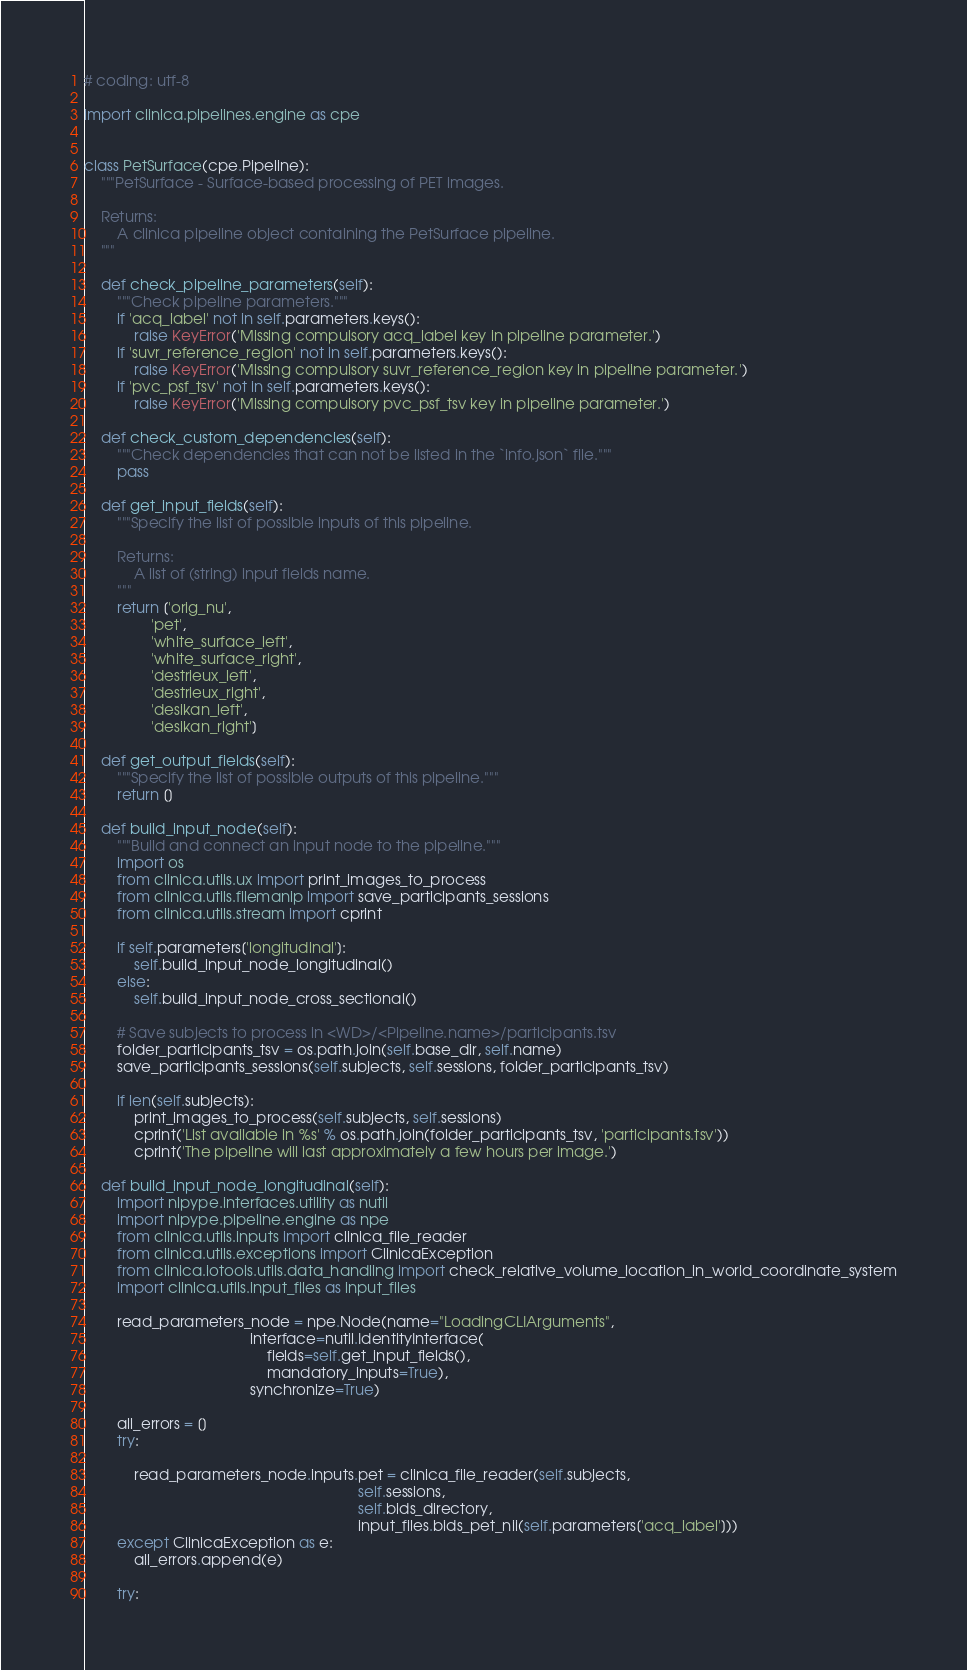<code> <loc_0><loc_0><loc_500><loc_500><_Python_># coding: utf-8

import clinica.pipelines.engine as cpe


class PetSurface(cpe.Pipeline):
    """PetSurface - Surface-based processing of PET images.

    Returns:
        A clinica pipeline object containing the PetSurface pipeline.
    """

    def check_pipeline_parameters(self):
        """Check pipeline parameters."""
        if 'acq_label' not in self.parameters.keys():
            raise KeyError('Missing compulsory acq_label key in pipeline parameter.')
        if 'suvr_reference_region' not in self.parameters.keys():
            raise KeyError('Missing compulsory suvr_reference_region key in pipeline parameter.')
        if 'pvc_psf_tsv' not in self.parameters.keys():
            raise KeyError('Missing compulsory pvc_psf_tsv key in pipeline parameter.')

    def check_custom_dependencies(self):
        """Check dependencies that can not be listed in the `info.json` file."""
        pass

    def get_input_fields(self):
        """Specify the list of possible inputs of this pipeline.

        Returns:
            A list of (string) input fields name.
        """
        return ['orig_nu',
                'pet',
                'white_surface_left',
                'white_surface_right',
                'destrieux_left',
                'destrieux_right',
                'desikan_left',
                'desikan_right']

    def get_output_fields(self):
        """Specify the list of possible outputs of this pipeline."""
        return []

    def build_input_node(self):
        """Build and connect an input node to the pipeline."""
        import os
        from clinica.utils.ux import print_images_to_process
        from clinica.utils.filemanip import save_participants_sessions
        from clinica.utils.stream import cprint

        if self.parameters['longitudinal']:
            self.build_input_node_longitudinal()
        else:
            self.build_input_node_cross_sectional()

        # Save subjects to process in <WD>/<Pipeline.name>/participants.tsv
        folder_participants_tsv = os.path.join(self.base_dir, self.name)
        save_participants_sessions(self.subjects, self.sessions, folder_participants_tsv)

        if len(self.subjects):
            print_images_to_process(self.subjects, self.sessions)
            cprint('List available in %s' % os.path.join(folder_participants_tsv, 'participants.tsv'))
            cprint('The pipeline will last approximately a few hours per image.')

    def build_input_node_longitudinal(self):
        import nipype.interfaces.utility as nutil
        import nipype.pipeline.engine as npe
        from clinica.utils.inputs import clinica_file_reader
        from clinica.utils.exceptions import ClinicaException
        from clinica.iotools.utils.data_handling import check_relative_volume_location_in_world_coordinate_system
        import clinica.utils.input_files as input_files

        read_parameters_node = npe.Node(name="LoadingCLIArguments",
                                        interface=nutil.IdentityInterface(
                                            fields=self.get_input_fields(),
                                            mandatory_inputs=True),
                                        synchronize=True)

        all_errors = []
        try:

            read_parameters_node.inputs.pet = clinica_file_reader(self.subjects,
                                                                  self.sessions,
                                                                  self.bids_directory,
                                                                  input_files.bids_pet_nii(self.parameters['acq_label']))
        except ClinicaException as e:
            all_errors.append(e)

        try:</code> 